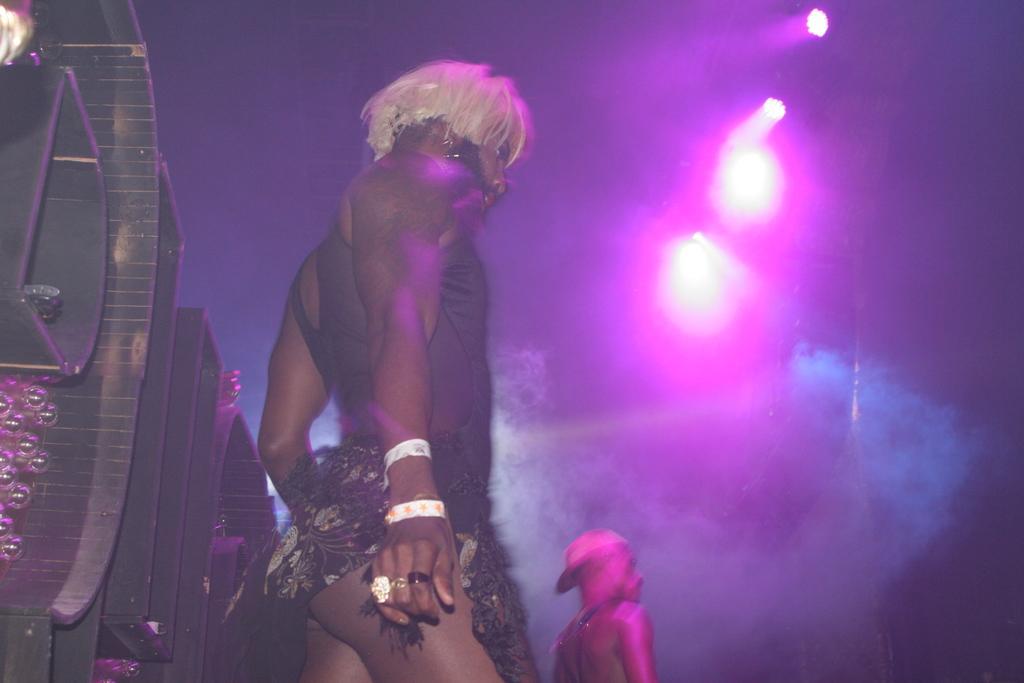In one or two sentences, can you explain what this image depicts? In this image we can see there are two persons wearing different costumes, back of them there is a metal structure. In the background there are some colorful lights. 